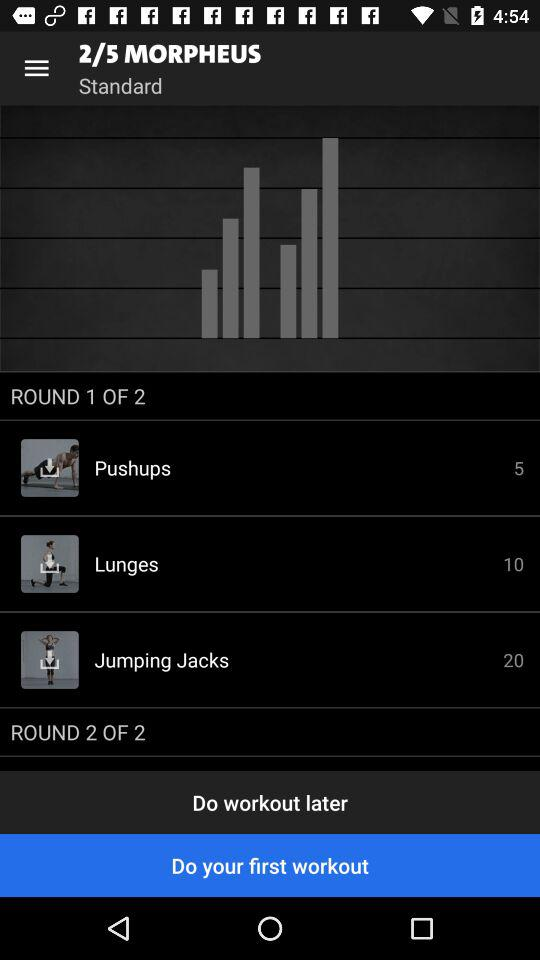How many rounds are there in this workout?
Answer the question using a single word or phrase. 2 